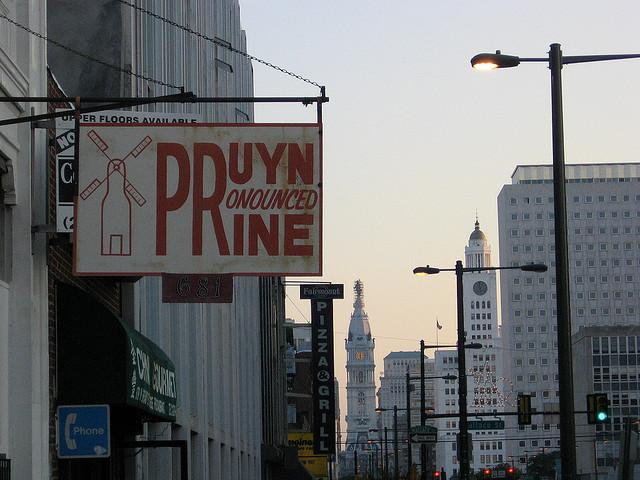Which way is illegal to turn on the upcoming cross street? Please explain your reasoning. right. One way street to left 